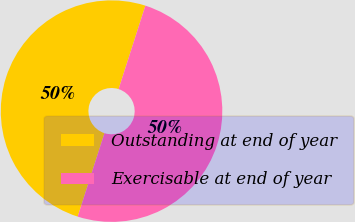Convert chart to OTSL. <chart><loc_0><loc_0><loc_500><loc_500><pie_chart><fcel>Outstanding at end of year<fcel>Exercisable at end of year<nl><fcel>50.0%<fcel>50.0%<nl></chart> 